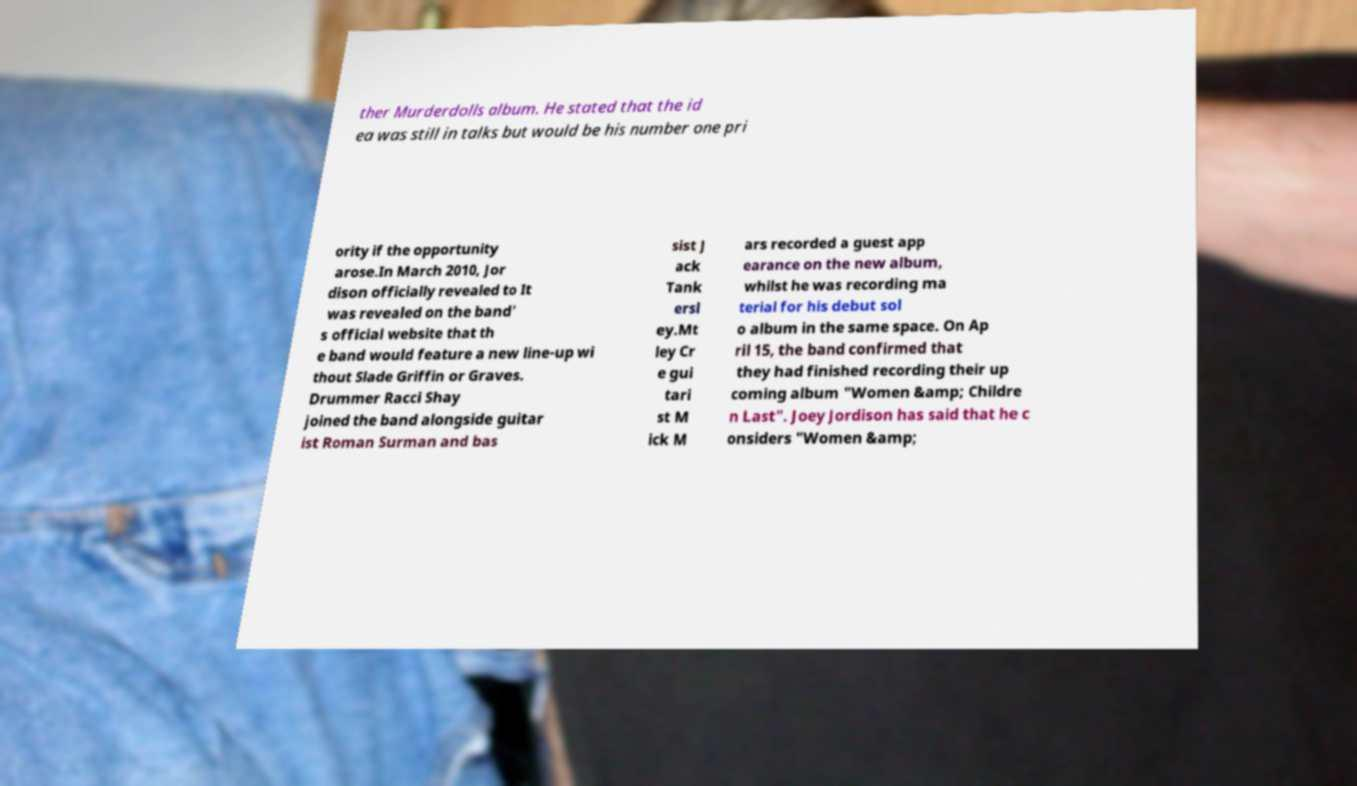Please read and relay the text visible in this image. What does it say? ther Murderdolls album. He stated that the id ea was still in talks but would be his number one pri ority if the opportunity arose.In March 2010, Jor dison officially revealed to It was revealed on the band' s official website that th e band would feature a new line-up wi thout Slade Griffin or Graves. Drummer Racci Shay joined the band alongside guitar ist Roman Surman and bas sist J ack Tank ersl ey.Mt ley Cr e gui tari st M ick M ars recorded a guest app earance on the new album, whilst he was recording ma terial for his debut sol o album in the same space. On Ap ril 15, the band confirmed that they had finished recording their up coming album "Women &amp; Childre n Last". Joey Jordison has said that he c onsiders "Women &amp; 